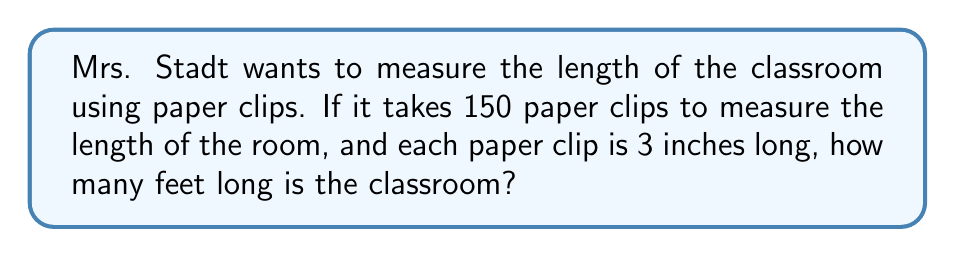Can you solve this math problem? Let's solve this problem step by step:

1. First, we need to find the total length in inches:
   $$ 150 \text{ paper clips} \times 3 \text{ inches per clip} = 450 \text{ inches} $$

2. Now, we need to convert inches to feet. We know that 1 foot = 12 inches.
   To convert, we divide the total inches by 12:
   $$ \frac{450 \text{ inches}}{12 \text{ inches/foot}} = 37.5 \text{ feet} $$

Therefore, the classroom is 37.5 feet long.
Answer: 37.5 feet 